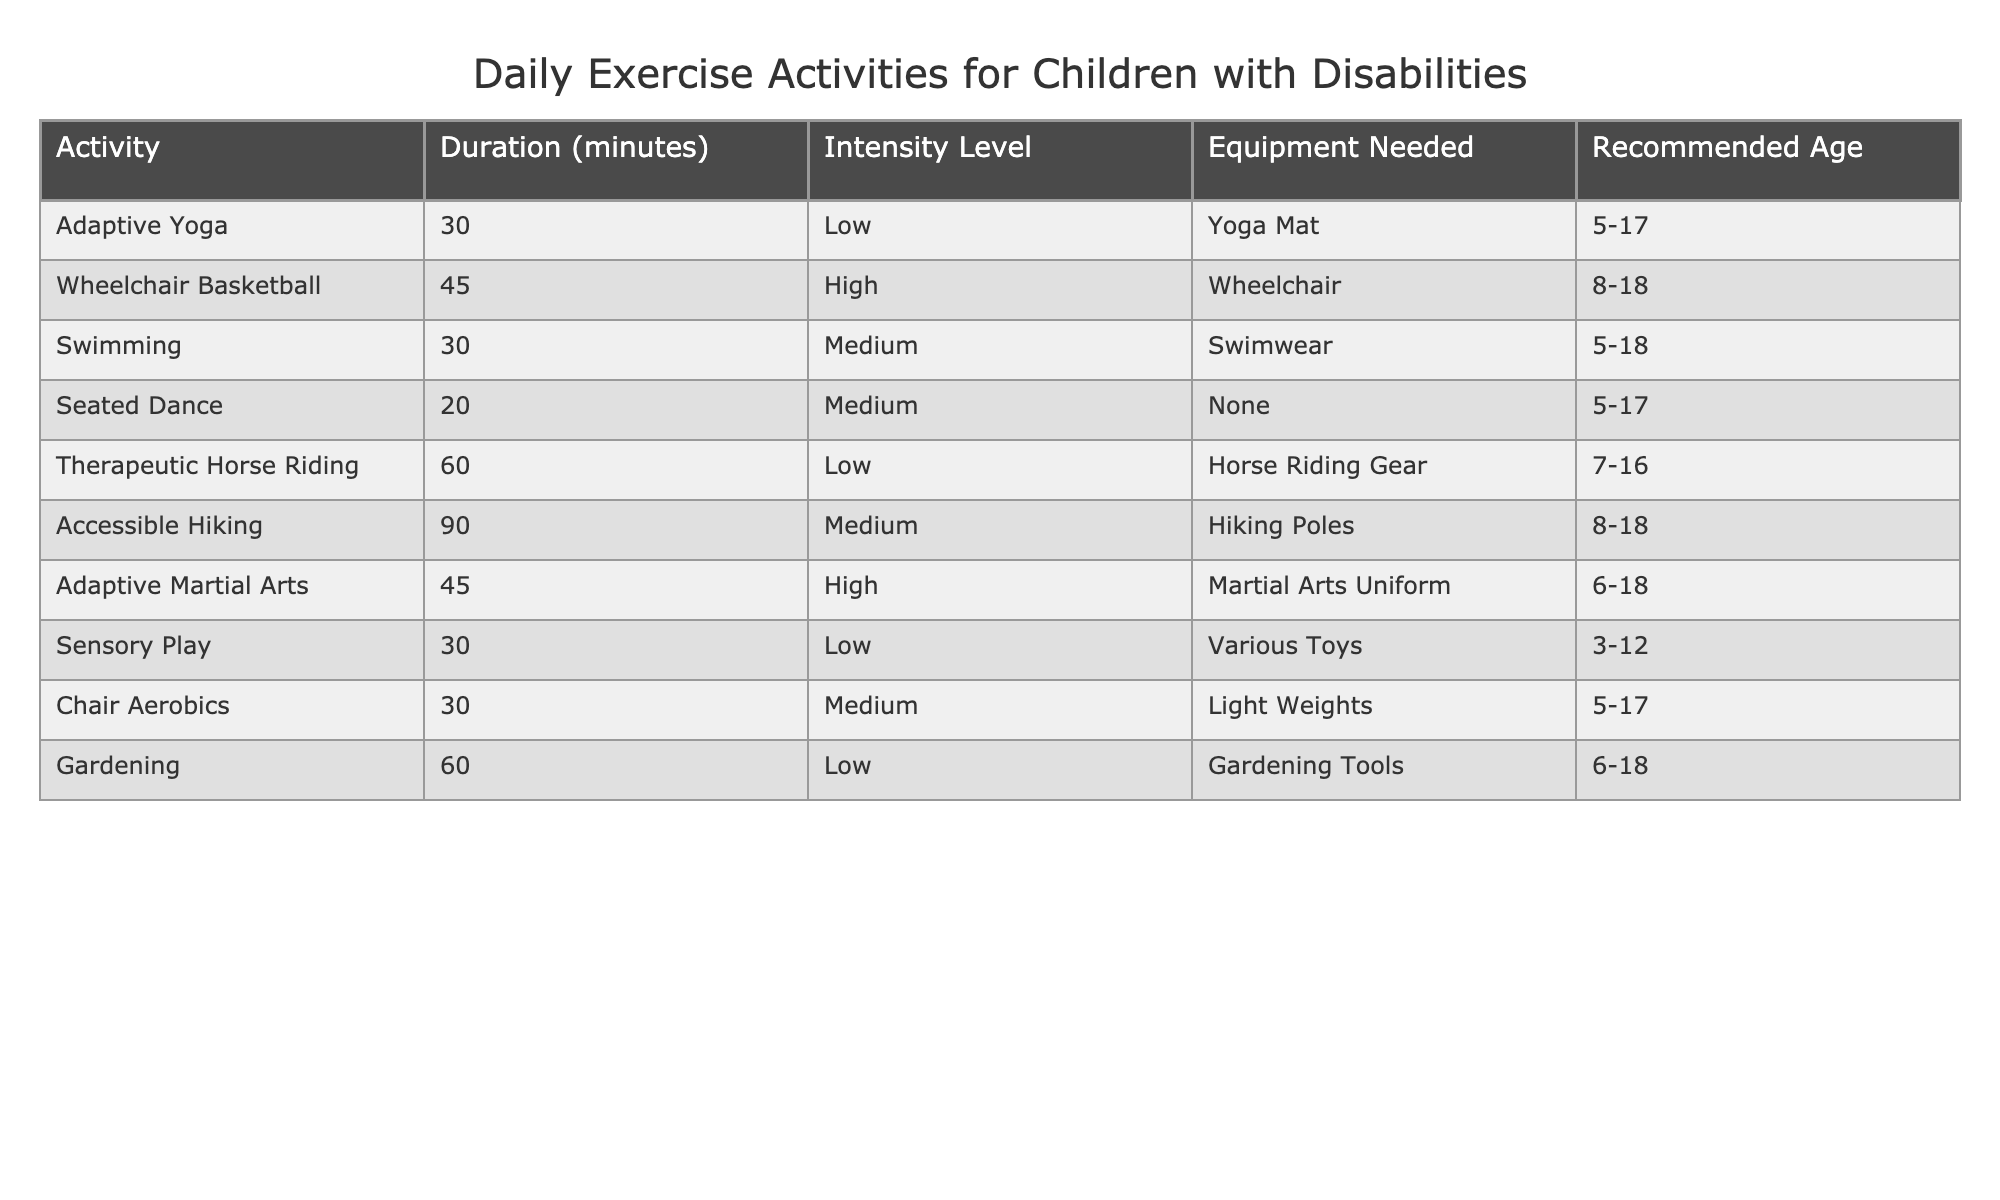What is the duration of Adaptive Yoga? The table lists Adaptive Yoga under the 'Activity' column with a corresponding 'Duration (minutes)' of 30.
Answer: 30 minutes Which activity requires a wheelchair? The activity that requires a wheelchair is listed as Wheelchair Basketball in the table.
Answer: Wheelchair Basketball How many activities have a medium intensity level? Counting the rows with "Medium" under 'Intensity Level', we find Swimming, Seated Dance, Accessible Hiking, and Chair Aerobics, totaling four activities.
Answer: 4 What is the recommended age for Therapeutic Horse Riding? The table indicates the recommended age for Therapeutic Horse Riding is between 7 to 16 years old.
Answer: 7-16 years Is Gardening considered a high-intensity activity? The table classifies Gardening as having a low intensity level, so it is not high intensity.
Answer: No Which activity has the longest duration? Checking the 'Duration (minutes)' column, Accessible Hiking has the longest duration at 90 minutes, longer than any other activity listed.
Answer: Accessible Hiking What is the average duration of the activities listed? To find the average, we sum the durations (30 + 45 + 30 + 20 + 60 + 90 + 45 + 30 + 60) = 410 minutes and divide by the total number of activities (9), resulting in an average of about 45.56 minutes.
Answer: 45.56 minutes How many activities are recommended for children aged 6 and up? The activities suitable for children aged 6 and up include Adaptive Martial Arts, Therapeutic Horse Riding, Gardening, and Chair Aerobics, yielding a total of four activities.
Answer: 4 What is the difference in duration between Swimming and Wheelchair Basketball? Swimming has a duration of 30 minutes and Wheelchair Basketball has 45 minutes; subtracting these gives 45 - 30 = 15 minutes difference.
Answer: 15 minutes Are there any activities that require no equipment? The table lists Seated Dance and Sensory Play as activities that require no equipment.
Answer: Yes 